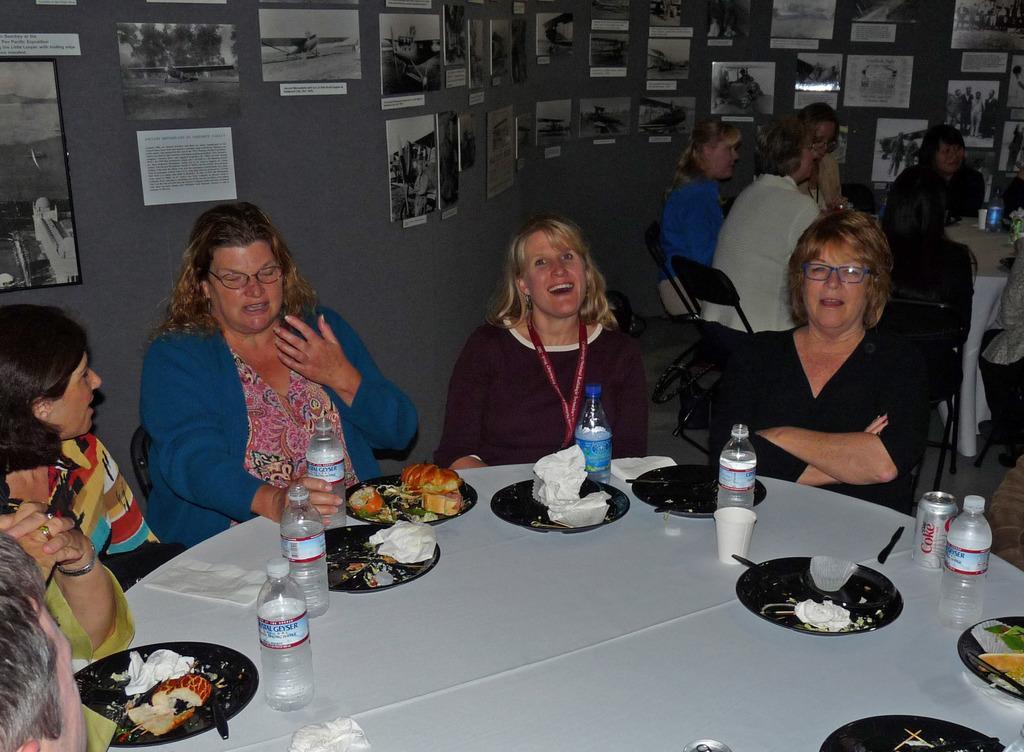Describe this image in one or two sentences. In this picture we have four people sitting on the chairs around the table on which there are some plates and bottles and around them there's a wall on with some pictures are posted and the other people sitting on the chairs in front of the tables. 